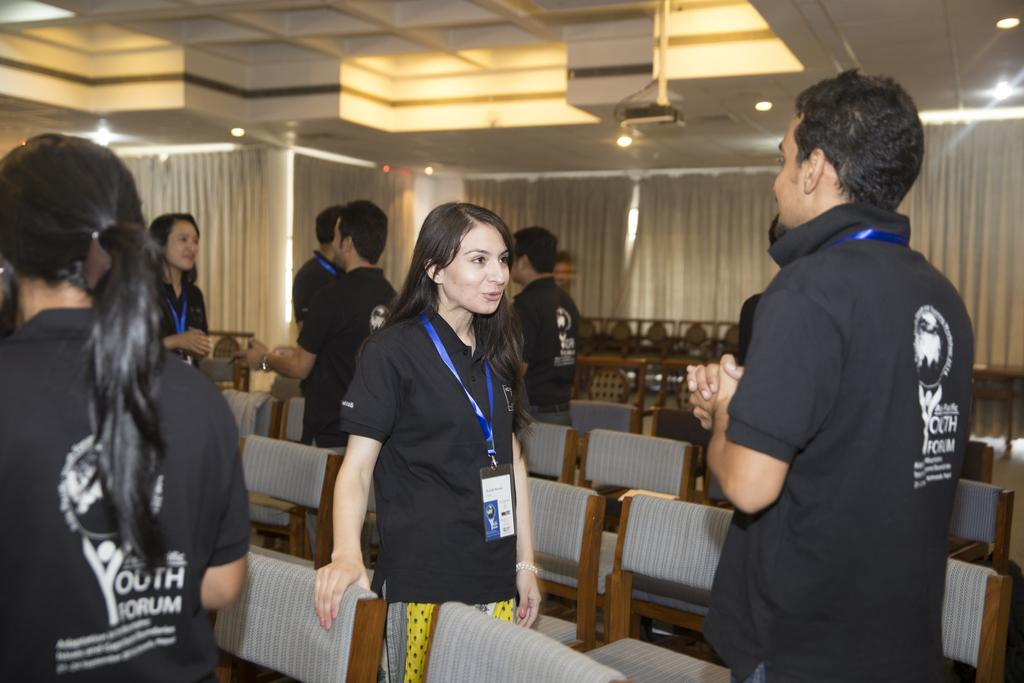How many people are present in the image? There are four people present in the image: a woman, a man, and two other women. What are the people in the image doing? The people are standing in the image, and there is a group of people standing in the background. What type of furniture is visible in the image? There are chairs in the image. What type of window treatment is present in the image? There is a curtain in the image. What type of lighting is present in the image? There is a ceiling light in the image. What type of equipment is visible in the image? There is a projector in the image. What type of education does the pet in the image have? There is no pet present in the image, so it is not possible to determine its education. 